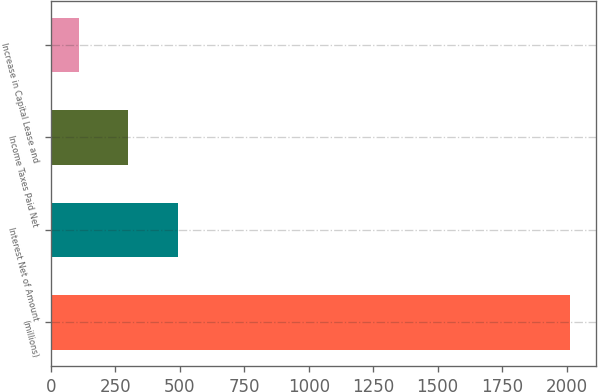<chart> <loc_0><loc_0><loc_500><loc_500><bar_chart><fcel>(millions)<fcel>Interest Net of Amount<fcel>Income Taxes Paid Net<fcel>Increase in Capital Lease and<nl><fcel>2014<fcel>490.8<fcel>300.4<fcel>110<nl></chart> 